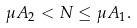<formula> <loc_0><loc_0><loc_500><loc_500>\mu A _ { 2 } < N \leq \mu A _ { 1 } .</formula> 